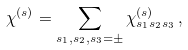Convert formula to latex. <formula><loc_0><loc_0><loc_500><loc_500>\chi ^ { ( s ) } = \sum _ { s _ { 1 } , s _ { 2 } , s _ { 3 } = \pm } \chi ^ { ( s ) } _ { s _ { 1 } s _ { 2 } s _ { 3 } } \, ,</formula> 